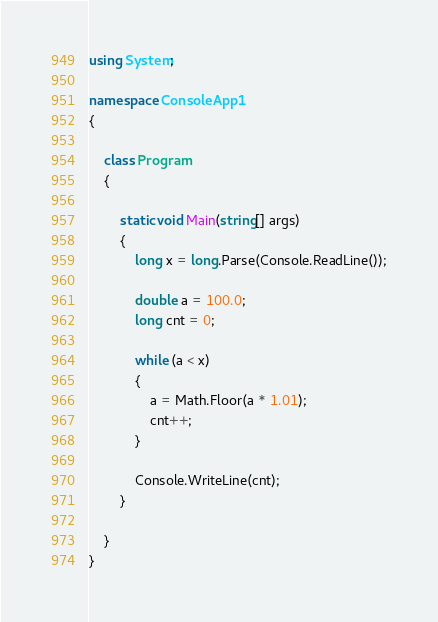Convert code to text. <code><loc_0><loc_0><loc_500><loc_500><_C#_>using System;

namespace ConsoleApp1
{

    class Program
    {

        static void Main(string[] args)
        {
            long x = long.Parse(Console.ReadLine());

            double a = 100.0;
            long cnt = 0;

            while (a < x)
            {
                a = Math.Floor(a * 1.01);
                cnt++;
            }

            Console.WriteLine(cnt);
        }

    }
}

</code> 